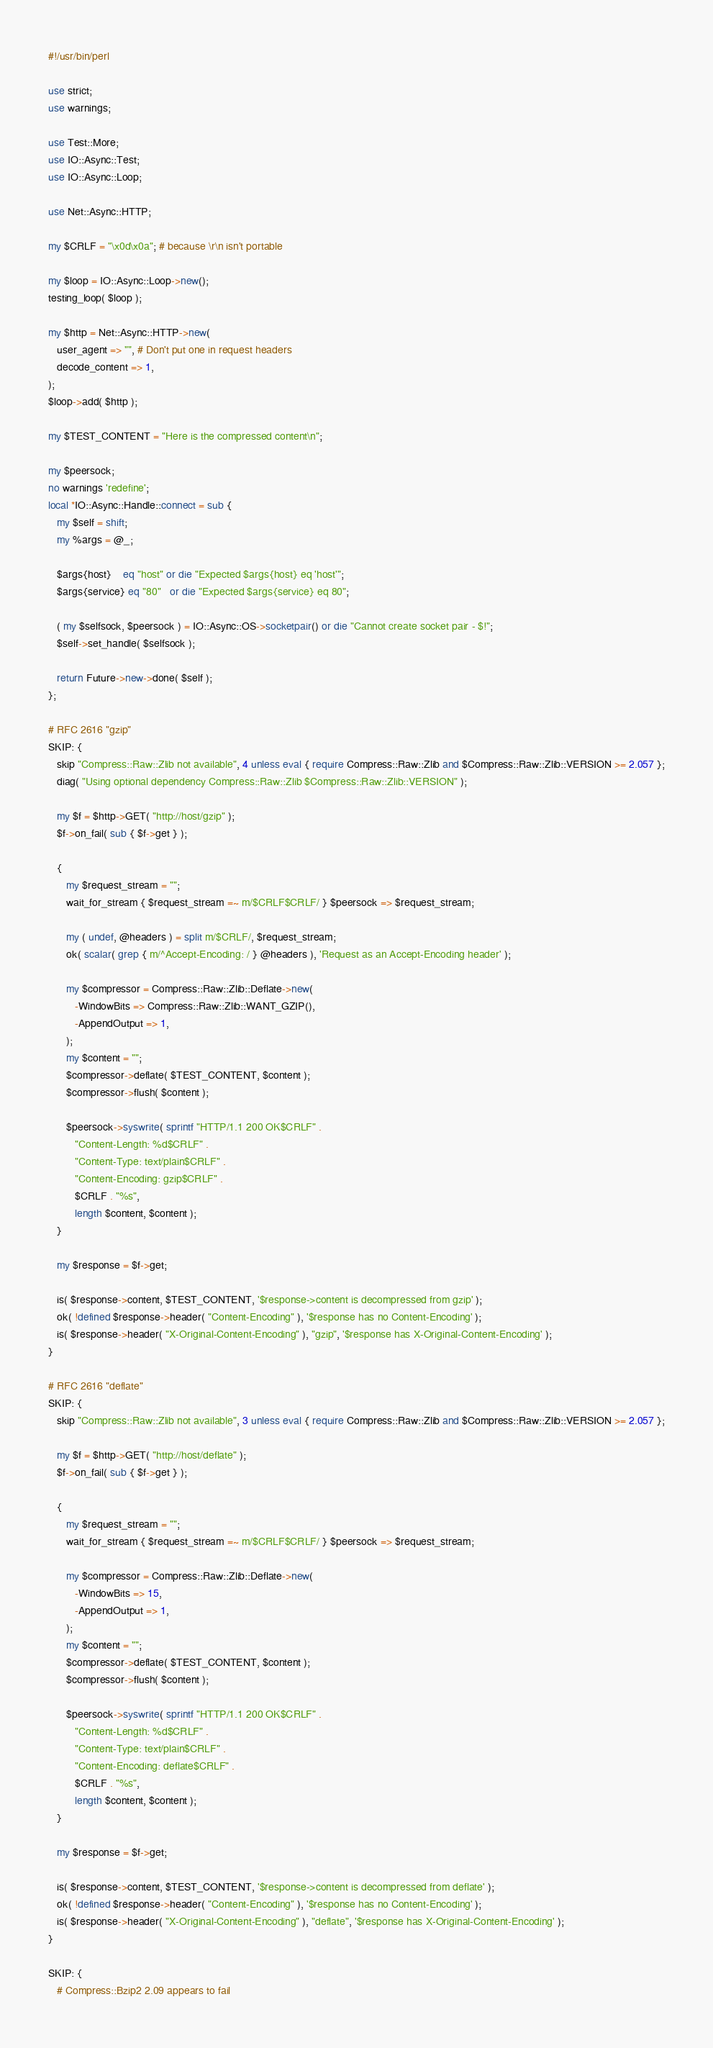<code> <loc_0><loc_0><loc_500><loc_500><_Perl_>#!/usr/bin/perl

use strict;
use warnings;

use Test::More;
use IO::Async::Test;
use IO::Async::Loop;

use Net::Async::HTTP;

my $CRLF = "\x0d\x0a"; # because \r\n isn't portable

my $loop = IO::Async::Loop->new();
testing_loop( $loop );

my $http = Net::Async::HTTP->new(
   user_agent => "", # Don't put one in request headers
   decode_content => 1,
);
$loop->add( $http );

my $TEST_CONTENT = "Here is the compressed content\n";

my $peersock;
no warnings 'redefine';
local *IO::Async::Handle::connect = sub {
   my $self = shift;
   my %args = @_;

   $args{host}    eq "host" or die "Expected $args{host} eq 'host'";
   $args{service} eq "80"   or die "Expected $args{service} eq 80";

   ( my $selfsock, $peersock ) = IO::Async::OS->socketpair() or die "Cannot create socket pair - $!";
   $self->set_handle( $selfsock );

   return Future->new->done( $self );
};

# RFC 2616 "gzip"
SKIP: {
   skip "Compress::Raw::Zlib not available", 4 unless eval { require Compress::Raw::Zlib and $Compress::Raw::Zlib::VERSION >= 2.057 };
   diag( "Using optional dependency Compress::Raw::Zlib $Compress::Raw::Zlib::VERSION" );

   my $f = $http->GET( "http://host/gzip" );
   $f->on_fail( sub { $f->get } );

   {
      my $request_stream = "";
      wait_for_stream { $request_stream =~ m/$CRLF$CRLF/ } $peersock => $request_stream;

      my ( undef, @headers ) = split m/$CRLF/, $request_stream;
      ok( scalar( grep { m/^Accept-Encoding: / } @headers ), 'Request as an Accept-Encoding header' );

      my $compressor = Compress::Raw::Zlib::Deflate->new(
         -WindowBits => Compress::Raw::Zlib::WANT_GZIP(),
         -AppendOutput => 1,
      );
      my $content = "";
      $compressor->deflate( $TEST_CONTENT, $content );
      $compressor->flush( $content );

      $peersock->syswrite( sprintf "HTTP/1.1 200 OK$CRLF" .
         "Content-Length: %d$CRLF" .
         "Content-Type: text/plain$CRLF" .
         "Content-Encoding: gzip$CRLF" .
         $CRLF . "%s",
         length $content, $content );
   }

   my $response = $f->get;

   is( $response->content, $TEST_CONTENT, '$response->content is decompressed from gzip' );
   ok( !defined $response->header( "Content-Encoding" ), '$response has no Content-Encoding' );
   is( $response->header( "X-Original-Content-Encoding" ), "gzip", '$response has X-Original-Content-Encoding' );
}

# RFC 2616 "deflate"
SKIP: {
   skip "Compress::Raw::Zlib not available", 3 unless eval { require Compress::Raw::Zlib and $Compress::Raw::Zlib::VERSION >= 2.057 };

   my $f = $http->GET( "http://host/deflate" );
   $f->on_fail( sub { $f->get } );

   {
      my $request_stream = "";
      wait_for_stream { $request_stream =~ m/$CRLF$CRLF/ } $peersock => $request_stream;

      my $compressor = Compress::Raw::Zlib::Deflate->new(
         -WindowBits => 15,
         -AppendOutput => 1,
      );
      my $content = "";
      $compressor->deflate( $TEST_CONTENT, $content );
      $compressor->flush( $content );

      $peersock->syswrite( sprintf "HTTP/1.1 200 OK$CRLF" .
         "Content-Length: %d$CRLF" .
         "Content-Type: text/plain$CRLF" .
         "Content-Encoding: deflate$CRLF" .
         $CRLF . "%s",
         length $content, $content );
   }

   my $response = $f->get;

   is( $response->content, $TEST_CONTENT, '$response->content is decompressed from deflate' );
   ok( !defined $response->header( "Content-Encoding" ), '$response has no Content-Encoding' );
   is( $response->header( "X-Original-Content-Encoding" ), "deflate", '$response has X-Original-Content-Encoding' );
}

SKIP: {
   # Compress::Bzip2 2.09 appears to fail</code> 